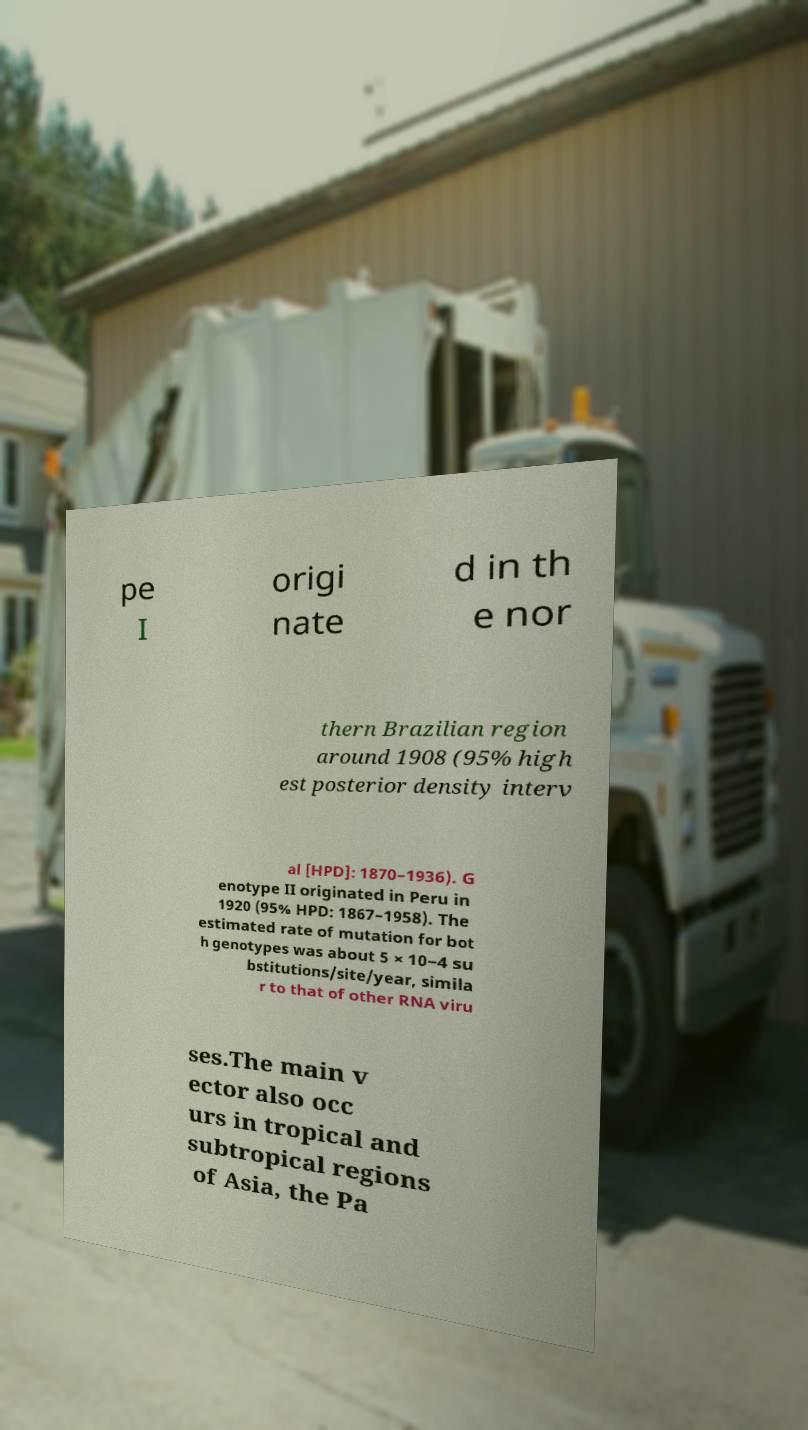Could you extract and type out the text from this image? pe I origi nate d in th e nor thern Brazilian region around 1908 (95% high est posterior density interv al [HPD]: 1870–1936). G enotype II originated in Peru in 1920 (95% HPD: 1867–1958). The estimated rate of mutation for bot h genotypes was about 5 × 10−4 su bstitutions/site/year, simila r to that of other RNA viru ses.The main v ector also occ urs in tropical and subtropical regions of Asia, the Pa 